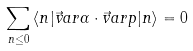Convert formula to latex. <formula><loc_0><loc_0><loc_500><loc_500>\sum _ { n \leq 0 } \, \langle n | \vec { v } a r { \alpha } \cdot \vec { v } a r { p } | n \rangle = 0</formula> 